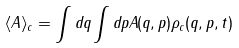Convert formula to latex. <formula><loc_0><loc_0><loc_500><loc_500>\langle A \rangle _ { c } = \int d q \int d p A ( q , p ) \rho _ { c } ( q , p , t )</formula> 